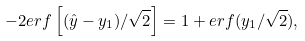<formula> <loc_0><loc_0><loc_500><loc_500>- 2 e r f \left [ ( \hat { y } - y _ { 1 } ) / \sqrt { 2 } \right ] = 1 + e r f ( y _ { 1 } / \sqrt { 2 } ) ,</formula> 